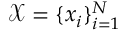<formula> <loc_0><loc_0><loc_500><loc_500>\mathcal { X } = \{ x _ { i } \} _ { i = 1 } ^ { N }</formula> 